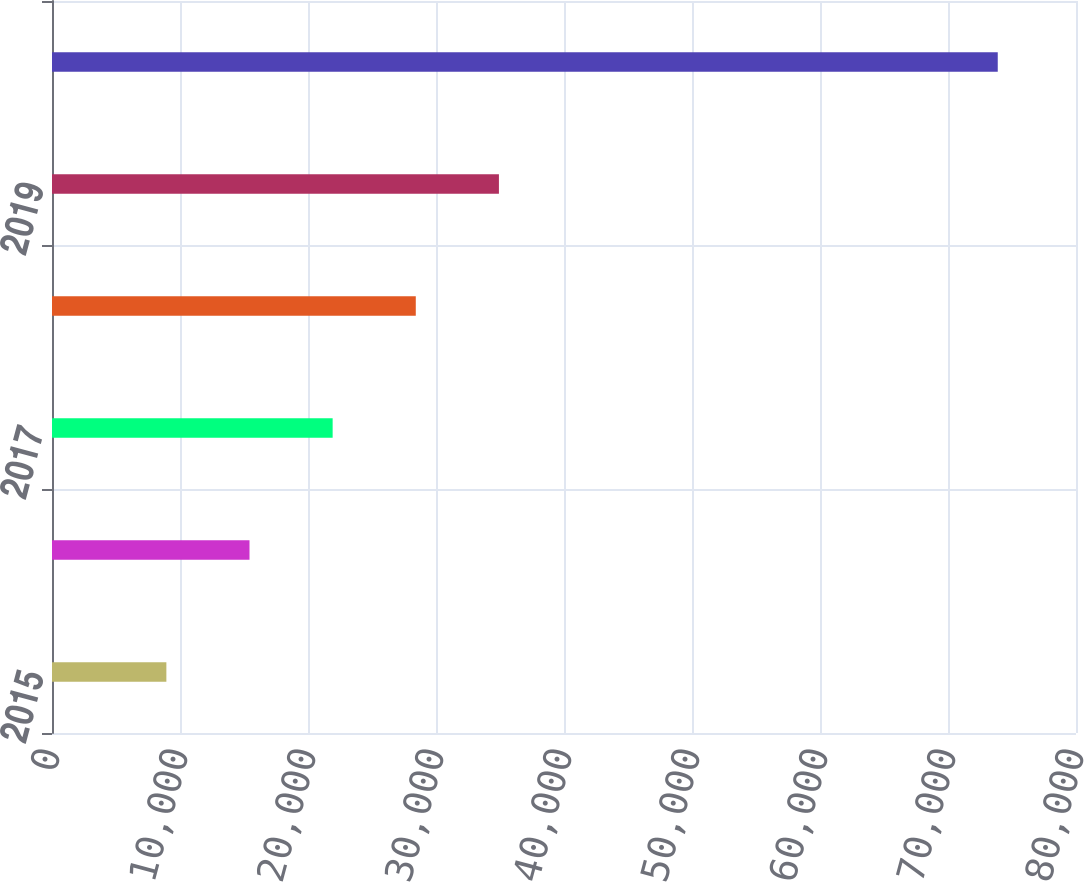Convert chart. <chart><loc_0><loc_0><loc_500><loc_500><bar_chart><fcel>2015<fcel>2016<fcel>2017<fcel>2018<fcel>2019<fcel>2020 - 2024<nl><fcel>8935<fcel>15430.2<fcel>21925.4<fcel>28420.6<fcel>34915.8<fcel>73887<nl></chart> 